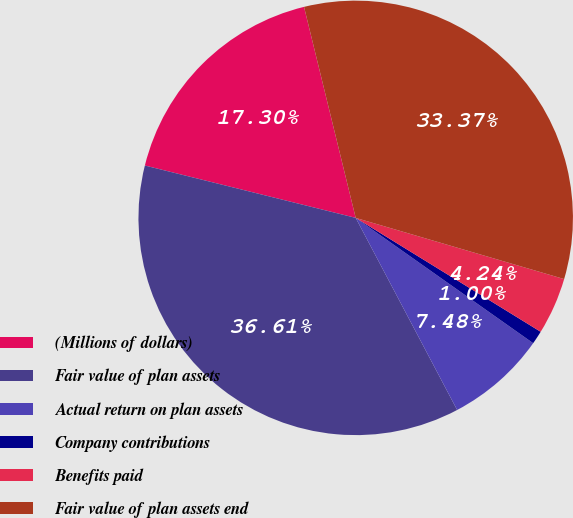Convert chart to OTSL. <chart><loc_0><loc_0><loc_500><loc_500><pie_chart><fcel>(Millions of dollars)<fcel>Fair value of plan assets<fcel>Actual return on plan assets<fcel>Company contributions<fcel>Benefits paid<fcel>Fair value of plan assets end<nl><fcel>17.3%<fcel>36.6%<fcel>7.48%<fcel>1.0%<fcel>4.24%<fcel>33.36%<nl></chart> 